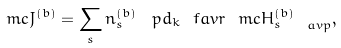Convert formula to latex. <formula><loc_0><loc_0><loc_500><loc_500>\ m c { J } ^ { ( b ) } = \sum _ { s } n _ { s } ^ { ( b ) } \, \ p d _ { k } \ f a v r { \ m c { H } _ { s } ^ { ( b ) } } _ { \ a v p } ,</formula> 